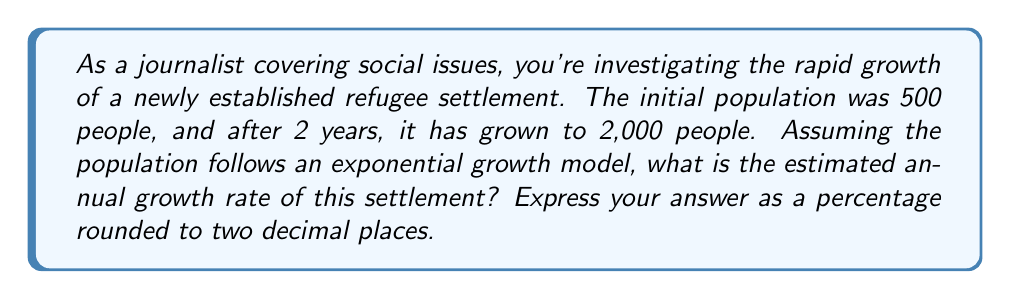Can you answer this question? To solve this problem, we'll use the exponential growth model:

$$P(t) = P_0 \cdot e^{rt}$$

Where:
$P(t)$ is the population at time $t$
$P_0$ is the initial population
$e$ is Euler's number (approximately 2.71828)
$r$ is the growth rate (we need to solve for this)
$t$ is the time period

Given:
$P_0 = 500$ (initial population)
$P(2) = 2000$ (population after 2 years)
$t = 2$ years

Let's plug these values into the equation:

$$2000 = 500 \cdot e^{2r}$$

Now, let's solve for $r$:

1) Divide both sides by 500:
   $$4 = e^{2r}$$

2) Take the natural logarithm of both sides:
   $$\ln(4) = \ln(e^{2r})$$

3) Simplify the right side using logarithm properties:
   $$\ln(4) = 2r$$

4) Divide both sides by 2:
   $$\frac{\ln(4)}{2} = r$$

5) Calculate the value of $r$:
   $$r = \frac{\ln(4)}{2} \approx 0.6931$$

6) Convert to a percentage:
   $$0.6931 \cdot 100\% \approx 69.31\%$$

Rounding to two decimal places, we get 69.31% as the annual growth rate.
Answer: 69.31% 